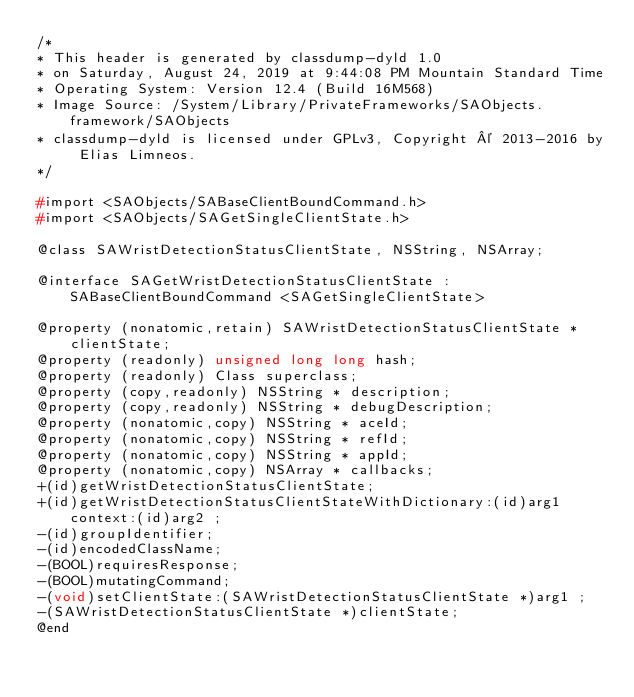<code> <loc_0><loc_0><loc_500><loc_500><_C_>/*
* This header is generated by classdump-dyld 1.0
* on Saturday, August 24, 2019 at 9:44:08 PM Mountain Standard Time
* Operating System: Version 12.4 (Build 16M568)
* Image Source: /System/Library/PrivateFrameworks/SAObjects.framework/SAObjects
* classdump-dyld is licensed under GPLv3, Copyright © 2013-2016 by Elias Limneos.
*/

#import <SAObjects/SABaseClientBoundCommand.h>
#import <SAObjects/SAGetSingleClientState.h>

@class SAWristDetectionStatusClientState, NSString, NSArray;

@interface SAGetWristDetectionStatusClientState : SABaseClientBoundCommand <SAGetSingleClientState>

@property (nonatomic,retain) SAWristDetectionStatusClientState * clientState; 
@property (readonly) unsigned long long hash; 
@property (readonly) Class superclass; 
@property (copy,readonly) NSString * description; 
@property (copy,readonly) NSString * debugDescription; 
@property (nonatomic,copy) NSString * aceId; 
@property (nonatomic,copy) NSString * refId; 
@property (nonatomic,copy) NSString * appId; 
@property (nonatomic,copy) NSArray * callbacks; 
+(id)getWristDetectionStatusClientState;
+(id)getWristDetectionStatusClientStateWithDictionary:(id)arg1 context:(id)arg2 ;
-(id)groupIdentifier;
-(id)encodedClassName;
-(BOOL)requiresResponse;
-(BOOL)mutatingCommand;
-(void)setClientState:(SAWristDetectionStatusClientState *)arg1 ;
-(SAWristDetectionStatusClientState *)clientState;
@end

</code> 